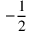Convert formula to latex. <formula><loc_0><loc_0><loc_500><loc_500>- { \frac { 1 } { 2 } }</formula> 